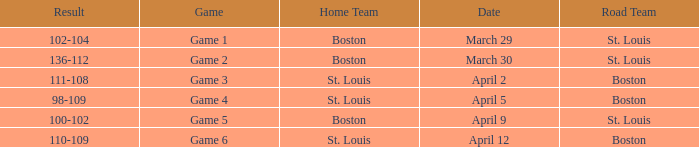On what Date is Game 3 with Boston Road Team? April 2. 